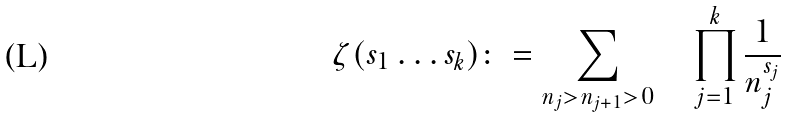Convert formula to latex. <formula><loc_0><loc_0><loc_500><loc_500>\zeta ( s _ { 1 } \dots s _ { k } ) \colon = \sum _ { n _ { j } > n _ { j + 1 } > 0 } \quad \prod _ { j = 1 } ^ { k } \frac { 1 } { n _ { j } ^ { s _ { j } } }</formula> 